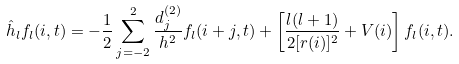Convert formula to latex. <formula><loc_0><loc_0><loc_500><loc_500>\hat { h } _ { l } f _ { l } ( i , t ) = - \frac { 1 } { 2 } \sum _ { j = - 2 } ^ { 2 } \frac { d _ { j } ^ { ( 2 ) } } { h ^ { 2 } } f _ { l } ( i + j , t ) + \left [ \frac { l ( l + 1 ) } { 2 [ r ( i ) ] ^ { 2 } } + V ( i ) \right ] f _ { l } ( i , t ) .</formula> 